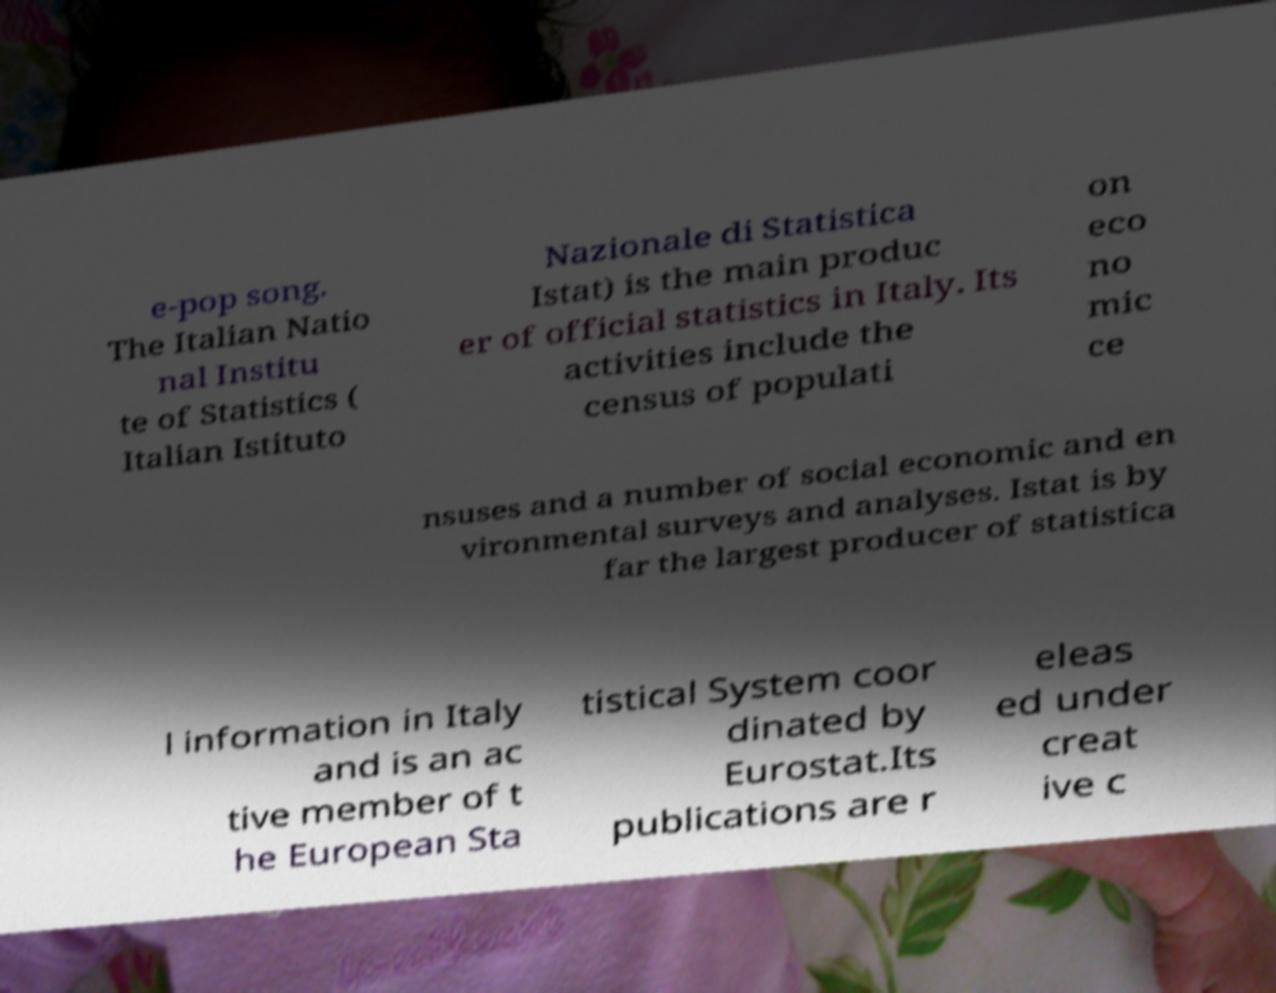Can you read and provide the text displayed in the image?This photo seems to have some interesting text. Can you extract and type it out for me? e-pop song. The Italian Natio nal Institu te of Statistics ( Italian Istituto Nazionale di Statistica Istat) is the main produc er of official statistics in Italy. Its activities include the census of populati on eco no mic ce nsuses and a number of social economic and en vironmental surveys and analyses. Istat is by far the largest producer of statistica l information in Italy and is an ac tive member of t he European Sta tistical System coor dinated by Eurostat.Its publications are r eleas ed under creat ive c 